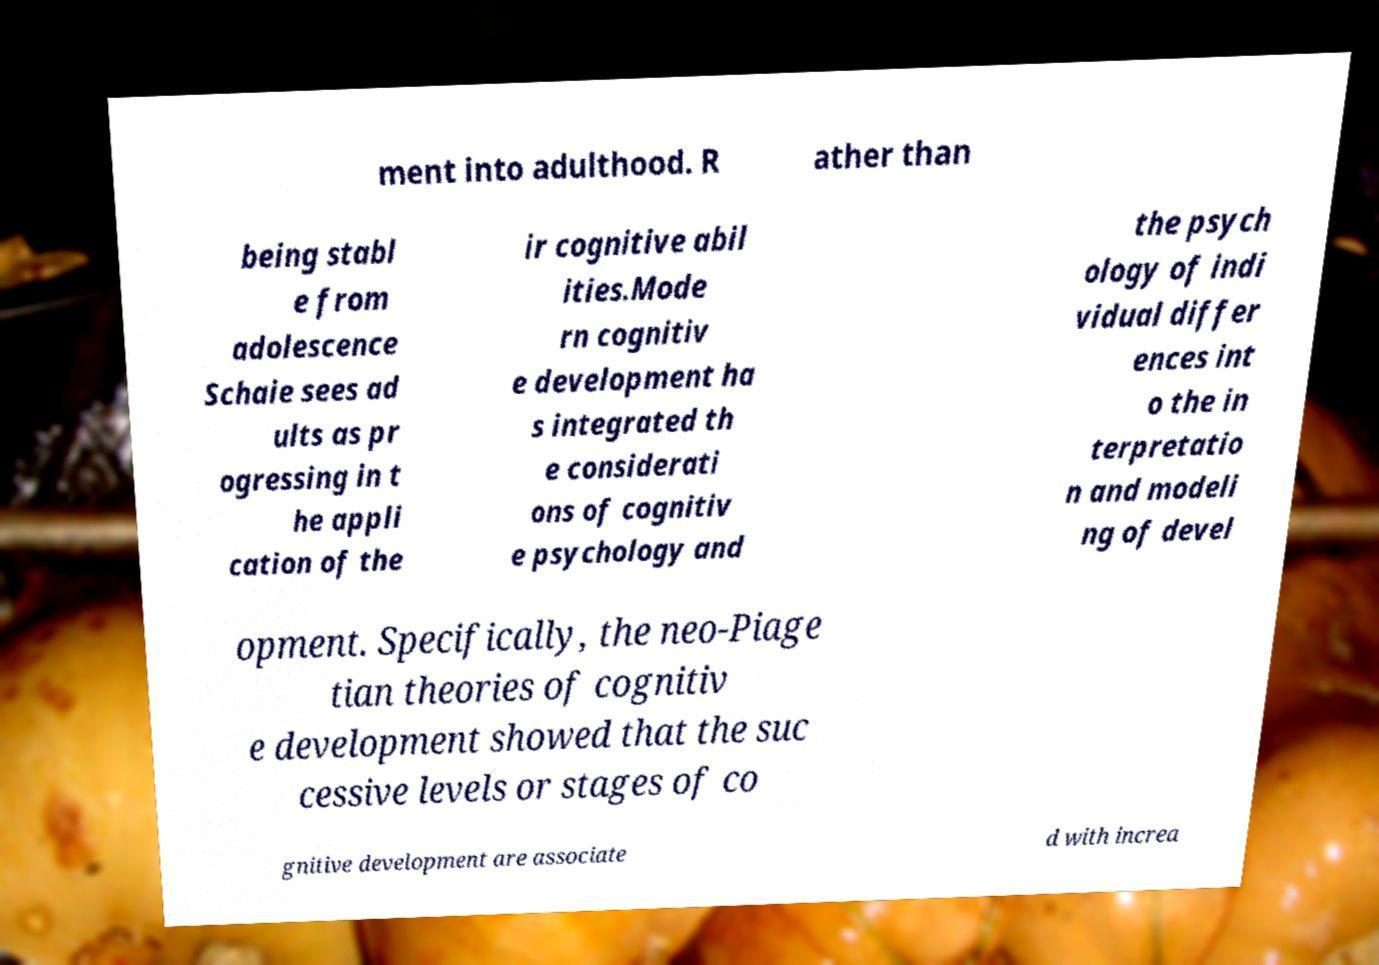There's text embedded in this image that I need extracted. Can you transcribe it verbatim? ment into adulthood. R ather than being stabl e from adolescence Schaie sees ad ults as pr ogressing in t he appli cation of the ir cognitive abil ities.Mode rn cognitiv e development ha s integrated th e considerati ons of cognitiv e psychology and the psych ology of indi vidual differ ences int o the in terpretatio n and modeli ng of devel opment. Specifically, the neo-Piage tian theories of cognitiv e development showed that the suc cessive levels or stages of co gnitive development are associate d with increa 